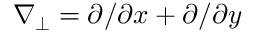Convert formula to latex. <formula><loc_0><loc_0><loc_500><loc_500>\nabla _ { \perp } = { \partial } / { \partial x } + { \partial } / { \partial y }</formula> 